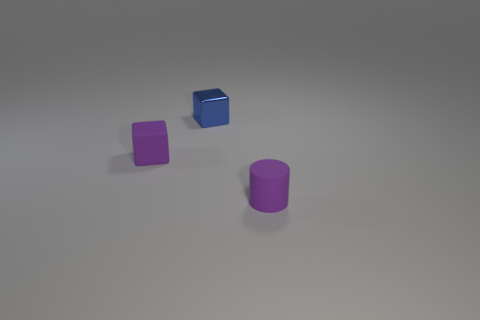Add 1 purple cylinders. How many objects exist? 4 Subtract all cylinders. How many objects are left? 2 Subtract 0 green cubes. How many objects are left? 3 Subtract all shiny objects. Subtract all tiny purple matte cylinders. How many objects are left? 1 Add 1 purple objects. How many purple objects are left? 3 Add 1 small purple rubber cylinders. How many small purple rubber cylinders exist? 2 